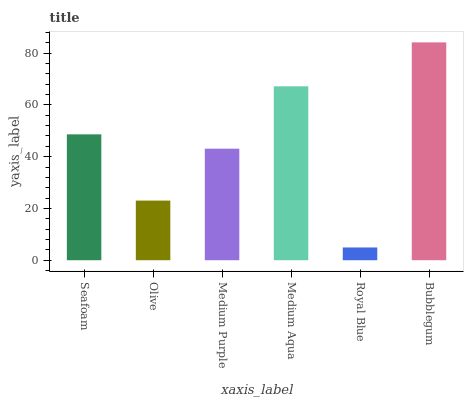Is Royal Blue the minimum?
Answer yes or no. Yes. Is Bubblegum the maximum?
Answer yes or no. Yes. Is Olive the minimum?
Answer yes or no. No. Is Olive the maximum?
Answer yes or no. No. Is Seafoam greater than Olive?
Answer yes or no. Yes. Is Olive less than Seafoam?
Answer yes or no. Yes. Is Olive greater than Seafoam?
Answer yes or no. No. Is Seafoam less than Olive?
Answer yes or no. No. Is Seafoam the high median?
Answer yes or no. Yes. Is Medium Purple the low median?
Answer yes or no. Yes. Is Olive the high median?
Answer yes or no. No. Is Medium Aqua the low median?
Answer yes or no. No. 